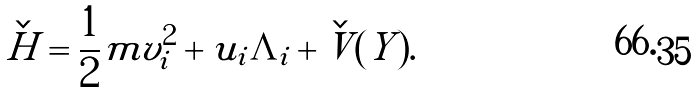<formula> <loc_0><loc_0><loc_500><loc_500>\check { H } = \frac { 1 } { 2 } m v _ { i } ^ { 2 } + u _ { i } \tilde { \Lambda } _ { i } + \check { V } ( Y ) .</formula> 